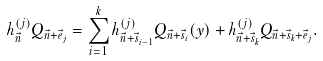<formula> <loc_0><loc_0><loc_500><loc_500>h _ { \vec { n } } ^ { ( j ) } Q _ { \vec { n } + \vec { e } _ { j } } = \sum _ { i = 1 } ^ { k } h _ { \vec { n } + \vec { s } _ { i - 1 } } ^ { ( j ) } Q _ { \vec { n } + \vec { s } _ { i } } ( y ) + h _ { \vec { n } + \vec { s } _ { k } } ^ { ( j ) } Q _ { \vec { n } + \vec { s } _ { k } + \vec { e } _ { j } } .</formula> 